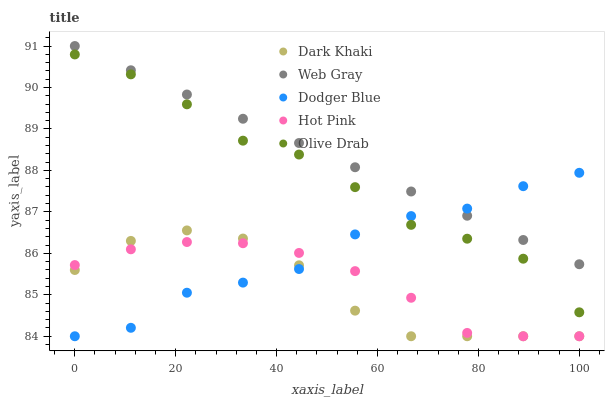Does Dark Khaki have the minimum area under the curve?
Answer yes or no. Yes. Does Web Gray have the maximum area under the curve?
Answer yes or no. Yes. Does Dodger Blue have the minimum area under the curve?
Answer yes or no. No. Does Dodger Blue have the maximum area under the curve?
Answer yes or no. No. Is Web Gray the smoothest?
Answer yes or no. Yes. Is Dodger Blue the roughest?
Answer yes or no. Yes. Is Dodger Blue the smoothest?
Answer yes or no. No. Is Web Gray the roughest?
Answer yes or no. No. Does Dark Khaki have the lowest value?
Answer yes or no. Yes. Does Web Gray have the lowest value?
Answer yes or no. No. Does Web Gray have the highest value?
Answer yes or no. Yes. Does Dodger Blue have the highest value?
Answer yes or no. No. Is Hot Pink less than Olive Drab?
Answer yes or no. Yes. Is Web Gray greater than Hot Pink?
Answer yes or no. Yes. Does Dodger Blue intersect Dark Khaki?
Answer yes or no. Yes. Is Dodger Blue less than Dark Khaki?
Answer yes or no. No. Is Dodger Blue greater than Dark Khaki?
Answer yes or no. No. Does Hot Pink intersect Olive Drab?
Answer yes or no. No. 